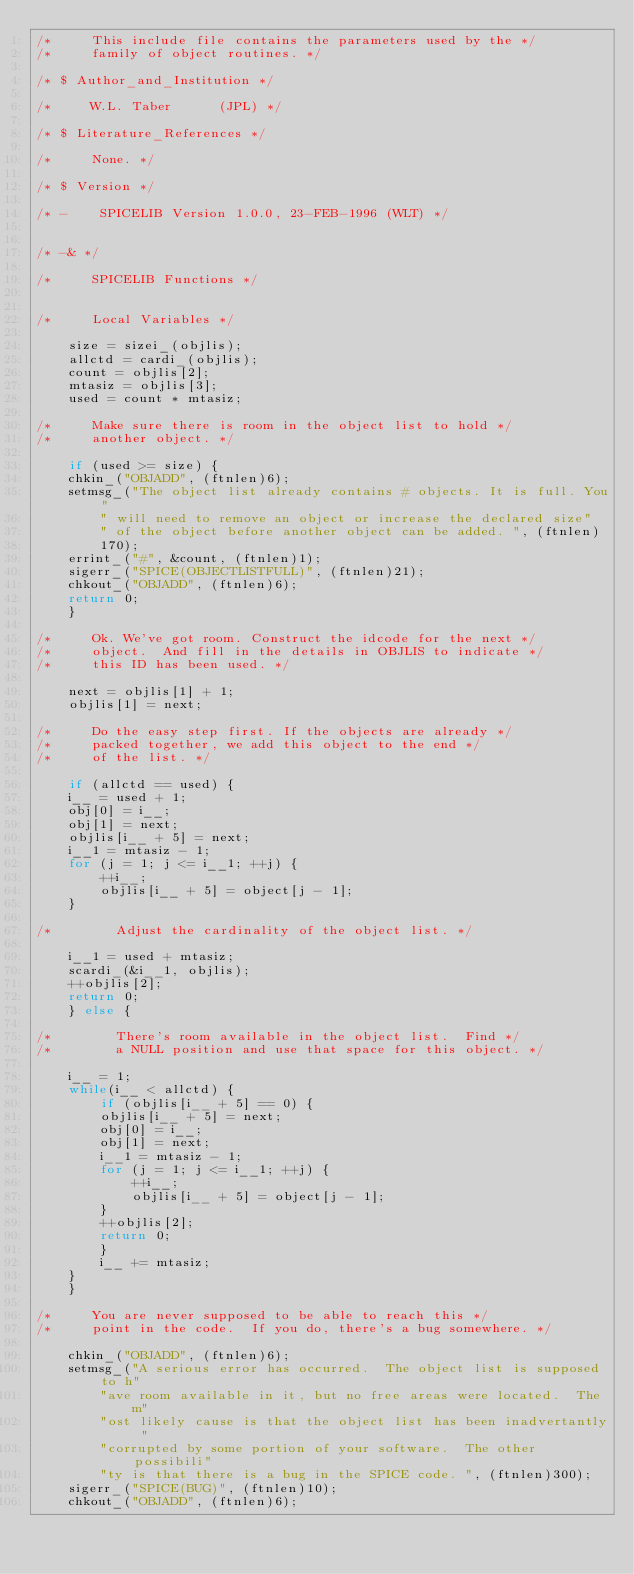Convert code to text. <code><loc_0><loc_0><loc_500><loc_500><_C_>/*     This include file contains the parameters used by the */
/*     family of object routines. */

/* $ Author_and_Institution */

/*     W.L. Taber      (JPL) */

/* $ Literature_References */

/*     None. */

/* $ Version */

/* -    SPICELIB Version 1.0.0, 23-FEB-1996 (WLT) */


/* -& */

/*     SPICELIB Functions */


/*     Local Variables */

    size = sizei_(objlis);
    allctd = cardi_(objlis);
    count = objlis[2];
    mtasiz = objlis[3];
    used = count * mtasiz;

/*     Make sure there is room in the object list to hold */
/*     another object. */

    if (used >= size) {
	chkin_("OBJADD", (ftnlen)6);
	setmsg_("The object list already contains # objects. It is full. You"
		" will need to remove an object or increase the declared size"
		" of the object before another object can be added. ", (ftnlen)
		170);
	errint_("#", &count, (ftnlen)1);
	sigerr_("SPICE(OBJECTLISTFULL)", (ftnlen)21);
	chkout_("OBJADD", (ftnlen)6);
	return 0;
    }

/*     Ok. We've got room. Construct the idcode for the next */
/*     object.  And fill in the details in OBJLIS to indicate */
/*     this ID has been used. */

    next = objlis[1] + 1;
    objlis[1] = next;

/*     Do the easy step first. If the objects are already */
/*     packed together, we add this object to the end */
/*     of the list. */

    if (allctd == used) {
	i__ = used + 1;
	obj[0] = i__;
	obj[1] = next;
	objlis[i__ + 5] = next;
	i__1 = mtasiz - 1;
	for (j = 1; j <= i__1; ++j) {
	    ++i__;
	    objlis[i__ + 5] = object[j - 1];
	}

/*        Adjust the cardinality of the object list. */

	i__1 = used + mtasiz;
	scardi_(&i__1, objlis);
	++objlis[2];
	return 0;
    } else {

/*        There's room available in the object list.  Find */
/*        a NULL position and use that space for this object. */

	i__ = 1;
	while(i__ < allctd) {
	    if (objlis[i__ + 5] == 0) {
		objlis[i__ + 5] = next;
		obj[0] = i__;
		obj[1] = next;
		i__1 = mtasiz - 1;
		for (j = 1; j <= i__1; ++j) {
		    ++i__;
		    objlis[i__ + 5] = object[j - 1];
		}
		++objlis[2];
		return 0;
	    }
	    i__ += mtasiz;
	}
    }

/*     You are never supposed to be able to reach this */
/*     point in the code.  If you do, there's a bug somewhere. */

    chkin_("OBJADD", (ftnlen)6);
    setmsg_("A serious error has occurred.  The object list is supposed to h"
	    "ave room available in it, but no free areas were located.  The m"
	    "ost likely cause is that the object list has been inadvertantly "
	    "corrupted by some portion of your software.  The other possibili"
	    "ty is that there is a bug in the SPICE code. ", (ftnlen)300);
    sigerr_("SPICE(BUG)", (ftnlen)10);
    chkout_("OBJADD", (ftnlen)6);</code> 